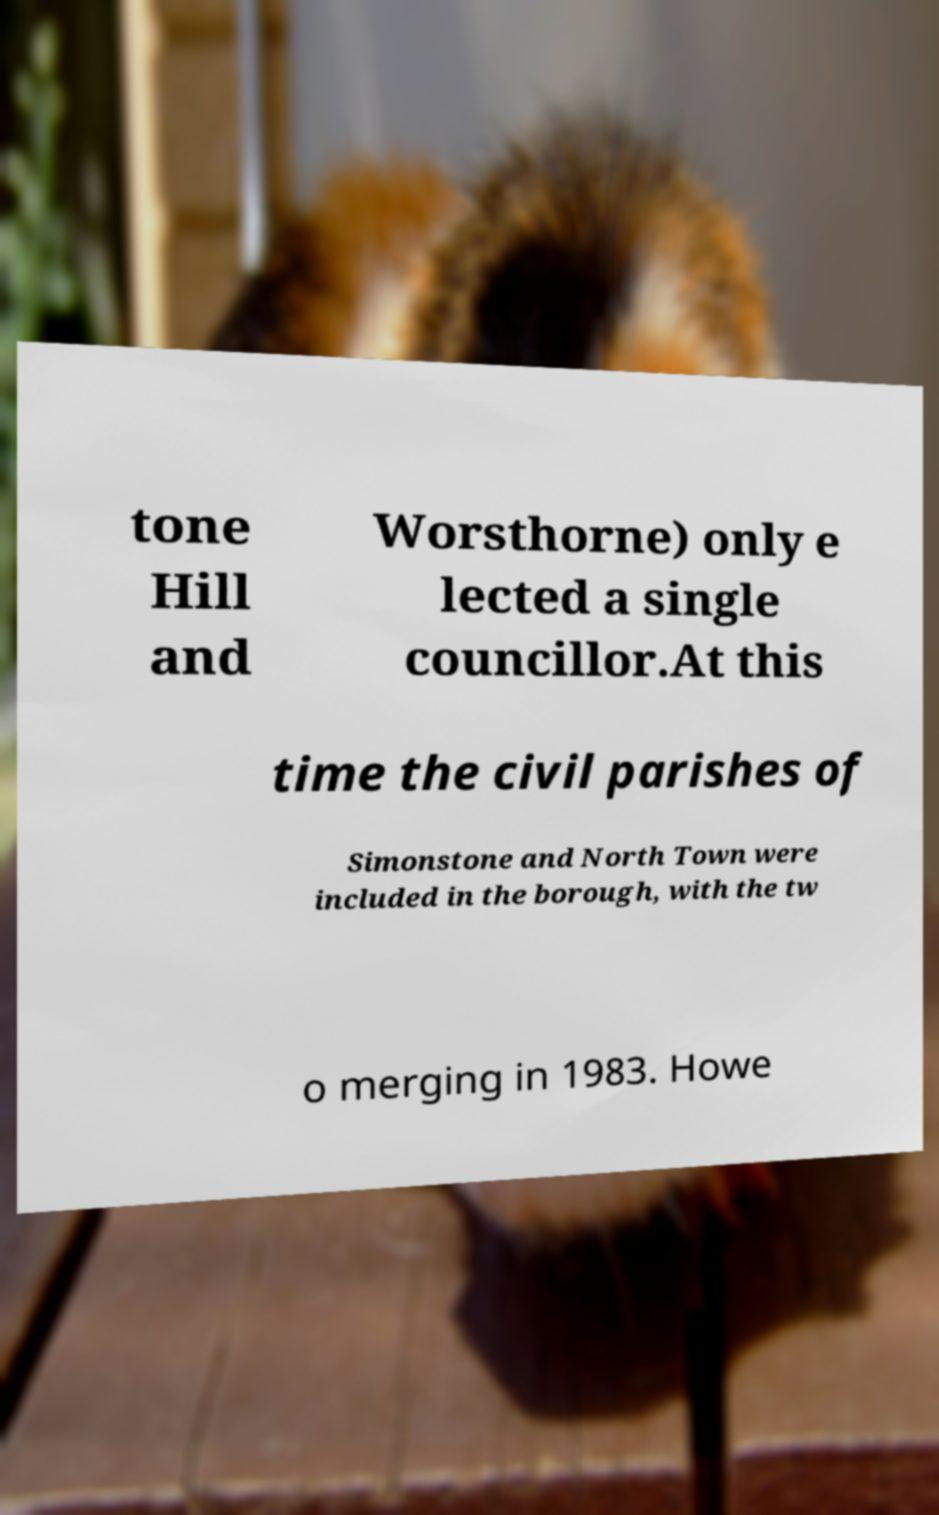Please read and relay the text visible in this image. What does it say? tone Hill and Worsthorne) only e lected a single councillor.At this time the civil parishes of Simonstone and North Town were included in the borough, with the tw o merging in 1983. Howe 